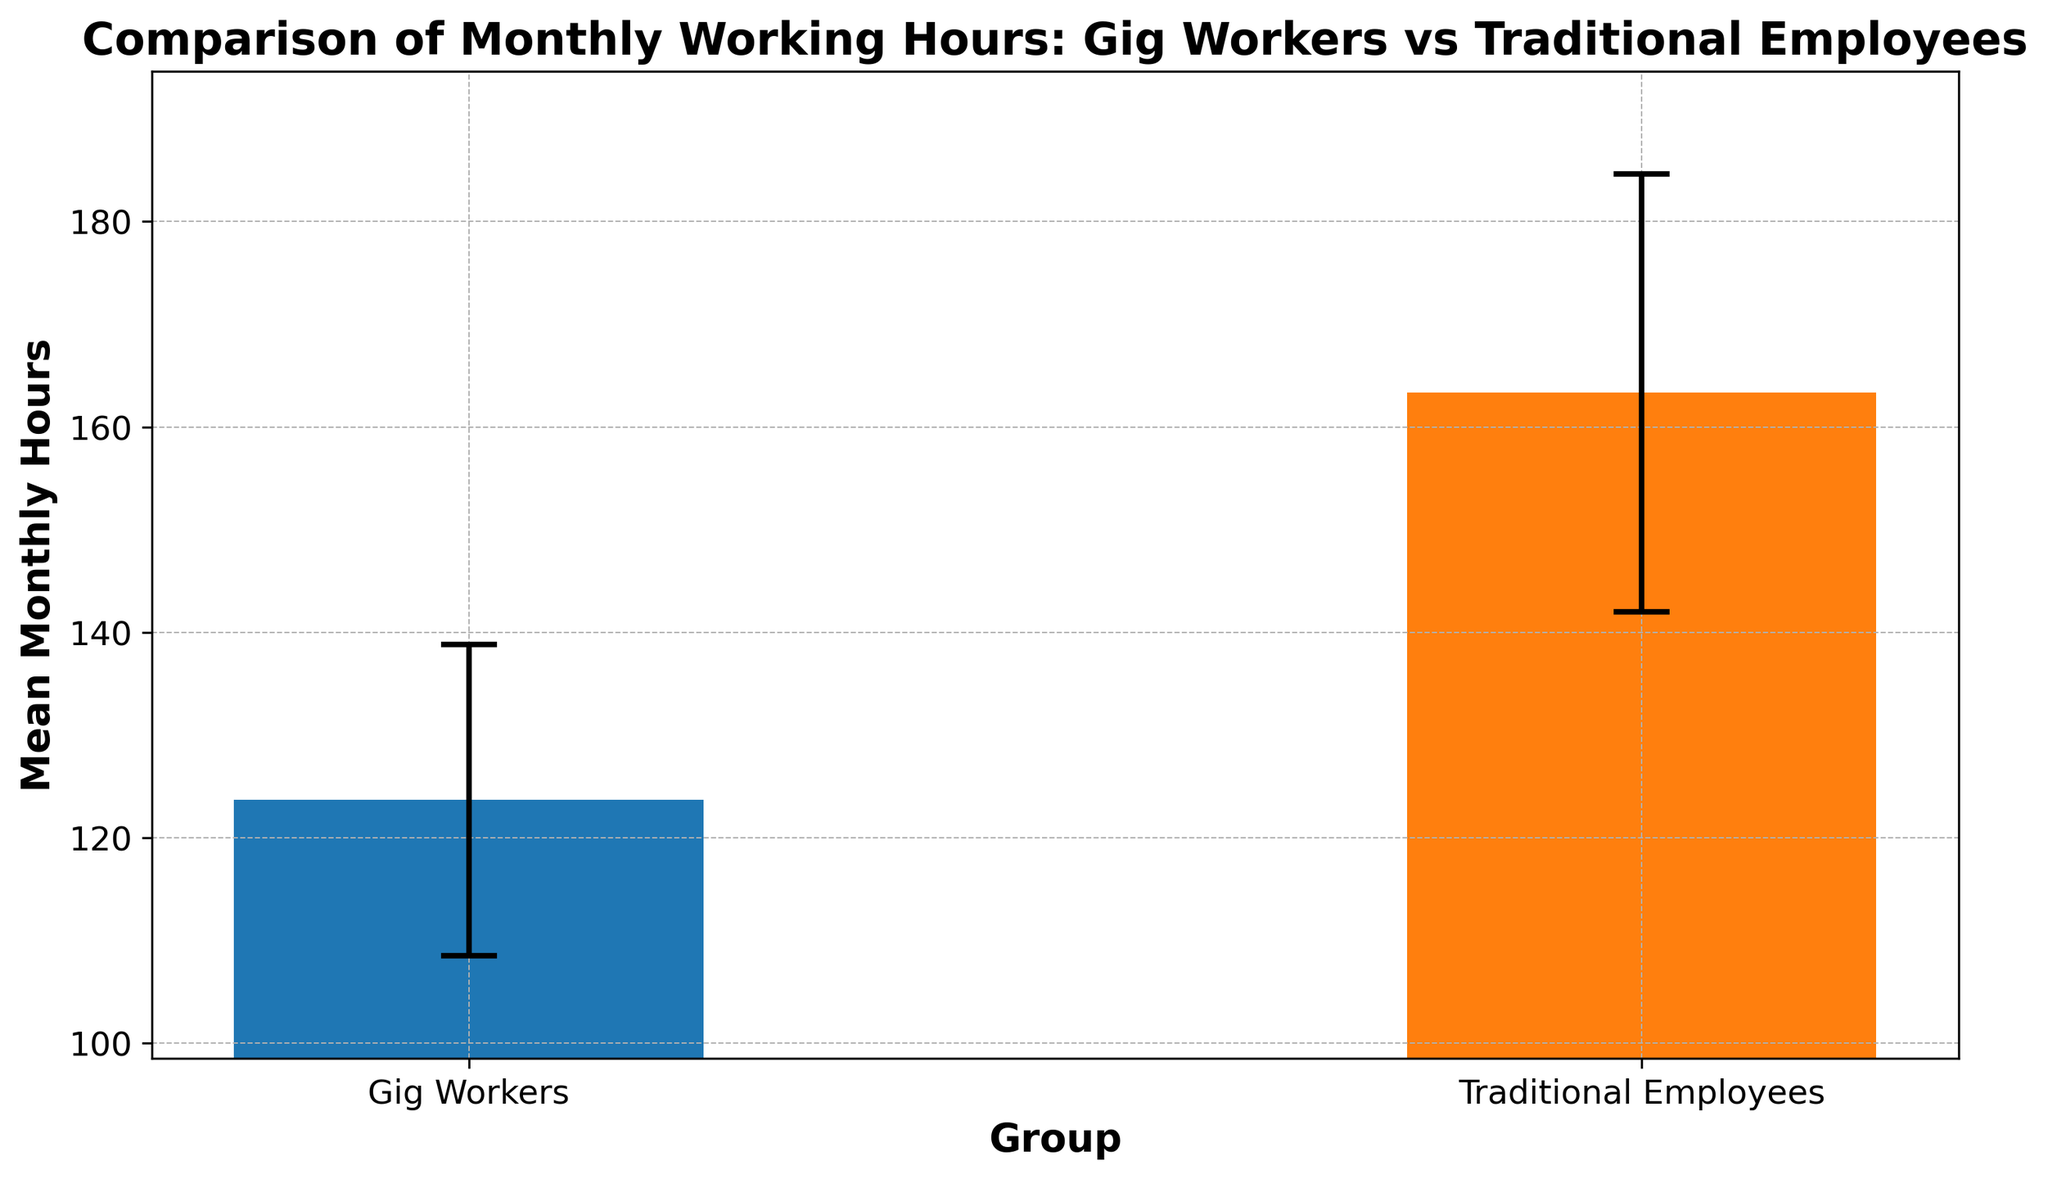What are the mean monthly working hours for Gig Workers and Traditional Employees? To find the mean monthly working hours, look at the height of their respective bars on the chart. The gig workers' bar is around 123 hours, and the traditional employees' bar is around 163 hours.
Answer: 123 hours for Gig Workers, 163 hours for Traditional Employees Which group has a higher mean monthly working hours? Compare the height of the two bars. The bar for traditional employees is taller than the one for gig workers.
Answer: Traditional Employees What is the difference in mean monthly working hours between Gig Workers and Traditional Employees? Subtract the mean monthly hours of gig workers from traditional employees. 163 - 123 = 40
Answer: 40 hours What is the average of the standard deviations for both groups? To find the average standard deviation, add the standard deviations for both groups and divide by two. (15.17 + 21.33) / 2 = 18.25
Answer: 18.25 hours Which group has a greater variability in monthly working hours? Compare the error bars, which indicate the standard deviation. The error bar for traditional employees is longer than that for gig workers.
Answer: Traditional Employees What is the highest mean monthly working hours stated in the chart? Look at the taller bar and read its height. The tallest bar represents traditional employees at approximately 163 hours.
Answer: 163 hours How much higher is the standard deviation for Traditional Employees than for Gig Workers? Subtract the standard deviation of gig workers from traditional employees: 21.33 - 15.17 = 6.16
Answer: 6.16 hours Considering the error bars, which group shows more consistent monthly working hours? The shorter error bars indicate less variability. The error bars for gig workers are shorter than those for traditional employees.
Answer: Gig Workers If an additional group had a mean monthly working hour of 145 hours with a standard deviation of 5 hours, how would it compare visually? This bar would be between the gig workers and traditional employees, specifically higher than gig workers and lower than traditional employees, with a very short error bar showing less variability.
Answer: In between Gig Workers and Traditional Employees, with less variability What is the mean monthly working hour difference between the group with the shortest and the longest error bars? The shortest error bar represents gig workers at 123 hours, and the longest error bar represents traditional employees at 163 hours. The difference is 163 - 123 = 40
Answer: 40 hours 